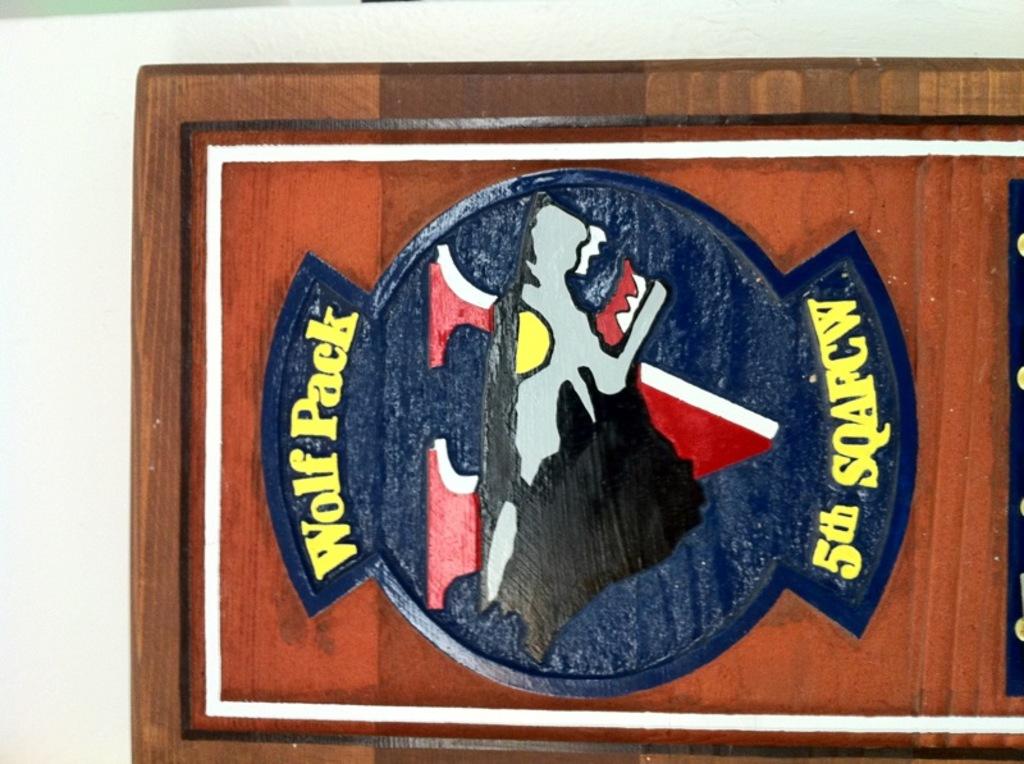What name can be read on the seats?
Ensure brevity in your answer.  Unanswerable. Is that for the boy scoouts?
Keep it short and to the point. Yes. 